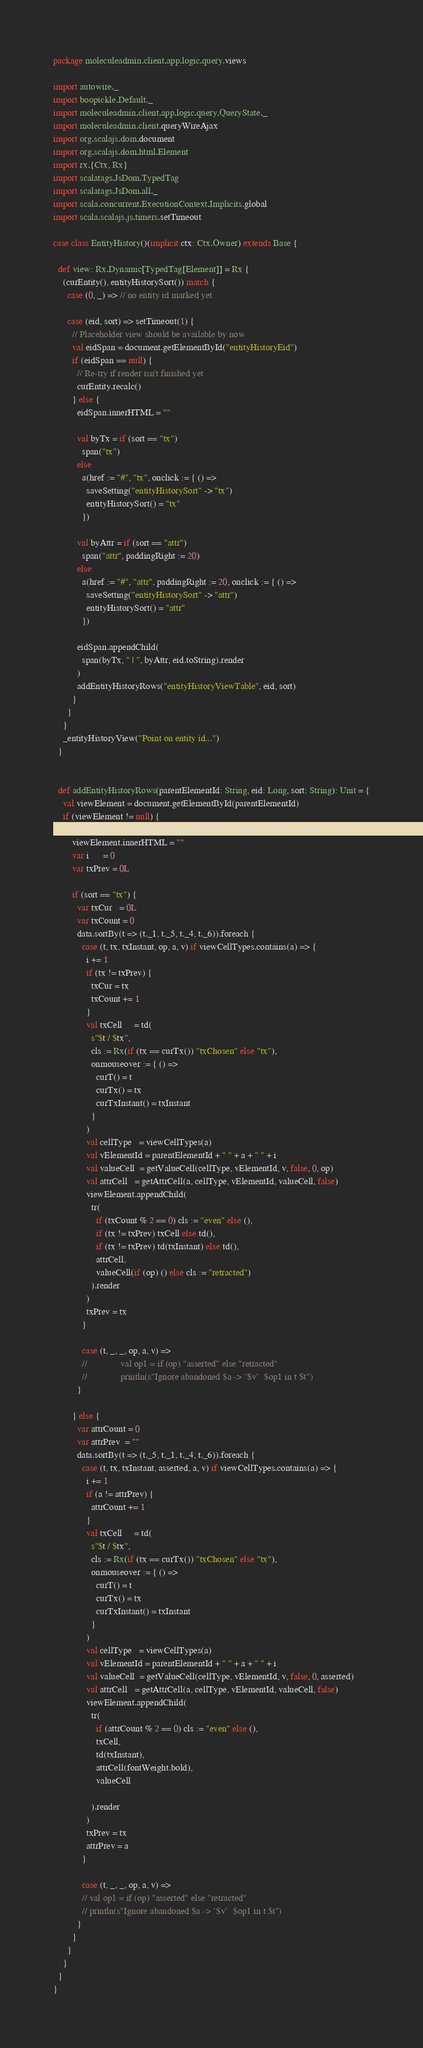Convert code to text. <code><loc_0><loc_0><loc_500><loc_500><_Scala_>package moleculeadmin.client.app.logic.query.views

import autowire._
import boopickle.Default._
import moleculeadmin.client.app.logic.query.QueryState._
import moleculeadmin.client.queryWireAjax
import org.scalajs.dom.document
import org.scalajs.dom.html.Element
import rx.{Ctx, Rx}
import scalatags.JsDom.TypedTag
import scalatags.JsDom.all._
import scala.concurrent.ExecutionContext.Implicits.global
import scala.scalajs.js.timers.setTimeout

case class EntityHistory()(implicit ctx: Ctx.Owner) extends Base {

  def view: Rx.Dynamic[TypedTag[Element]] = Rx {
    (curEntity(), entityHistorySort()) match {
      case (0, _) => // no entity id marked yet

      case (eid, sort) => setTimeout(1) {
        // Placeholder view should be available by now
        val eidSpan = document.getElementById("entityHistoryEid")
        if (eidSpan == null) {
          // Re-try if render isn't finished yet
          curEntity.recalc()
        } else {
          eidSpan.innerHTML = ""

          val byTx = if (sort == "tx")
            span("tx")
          else
            a(href := "#", "tx", onclick := { () =>
              saveSetting("entityHistorySort" -> "tx")
              entityHistorySort() = "tx"
            })

          val byAttr = if (sort == "attr")
            span("attr", paddingRight := 20)
          else
            a(href := "#", "attr", paddingRight := 20, onclick := { () =>
              saveSetting("entityHistorySort" -> "attr")
              entityHistorySort() = "attr"
            })

          eidSpan.appendChild(
            span(byTx, " | ", byAttr, eid.toString).render
          )
          addEntityHistoryRows("entityHistoryViewTable", eid, sort)
        }
      }
    }
    _entityHistoryView("Point on entity id...")
  }


  def addEntityHistoryRows(parentElementId: String, eid: Long, sort: String): Unit = {
    val viewElement = document.getElementById(parentElementId)
    if (viewElement != null) {
      queryWireAjax().getEntityHistory(db, eid, enumAttrs).call().foreach { data =>
        viewElement.innerHTML = ""
        var i      = 0
        var txPrev = 0L

        if (sort == "tx") {
          var txCur   = 0L
          var txCount = 0
          data.sortBy(t => (t._1, t._5, t._4, t._6)).foreach {
            case (t, tx, txInstant, op, a, v) if viewCellTypes.contains(a) => {
              i += 1
              if (tx != txPrev) {
                txCur = tx
                txCount += 1
              }
              val txCell     = td(
                s"$t / $tx",
                cls := Rx(if (tx == curTx()) "txChosen" else "tx"),
                onmouseover := { () =>
                  curT() = t
                  curTx() = tx
                  curTxInstant() = txInstant
                }
              )
              val cellType   = viewCellTypes(a)
              val vElementId = parentElementId + " " + a + " " + i
              val valueCell  = getValueCell(cellType, vElementId, v, false, 0, op)
              val attrCell   = getAttrCell(a, cellType, vElementId, valueCell, false)
              viewElement.appendChild(
                tr(
                  if (txCount % 2 == 0) cls := "even" else (),
                  if (tx != txPrev) txCell else td(),
                  if (tx != txPrev) td(txInstant) else td(),
                  attrCell,
                  valueCell(if (op) () else cls := "retracted")
                ).render
              )
              txPrev = tx
            }

            case (t, _, _, op, a, v) =>
            //              val op1 = if (op) "asserted" else "retracted"
            //              println(s"Ignore abandoned $a -> `$v`  $op1 in t $t")
          }

        } else {
          var attrCount = 0
          var attrPrev  = ""
          data.sortBy(t => (t._5, t._1, t._4, t._6)).foreach {
            case (t, tx, txInstant, asserted, a, v) if viewCellTypes.contains(a) => {
              i += 1
              if (a != attrPrev) {
                attrCount += 1
              }
              val txCell     = td(
                s"$t / $tx",
                cls := Rx(if (tx == curTx()) "txChosen" else "tx"),
                onmouseover := { () =>
                  curT() = t
                  curTx() = tx
                  curTxInstant() = txInstant
                }
              )
              val cellType   = viewCellTypes(a)
              val vElementId = parentElementId + " " + a + " " + i
              val valueCell  = getValueCell(cellType, vElementId, v, false, 0, asserted)
              val attrCell   = getAttrCell(a, cellType, vElementId, valueCell, false)
              viewElement.appendChild(
                tr(
                  if (attrCount % 2 == 0) cls := "even" else (),
                  txCell,
                  td(txInstant),
                  attrCell(fontWeight.bold),
                  valueCell

                ).render
              )
              txPrev = tx
              attrPrev = a
            }

            case (t, _, _, op, a, v) =>
            // val op1 = if (op) "asserted" else "retracted"
            // println(s"Ignore abandoned $a -> `$v`  $op1 in t $t")
          }
        }
      }
    }
  }
}
</code> 